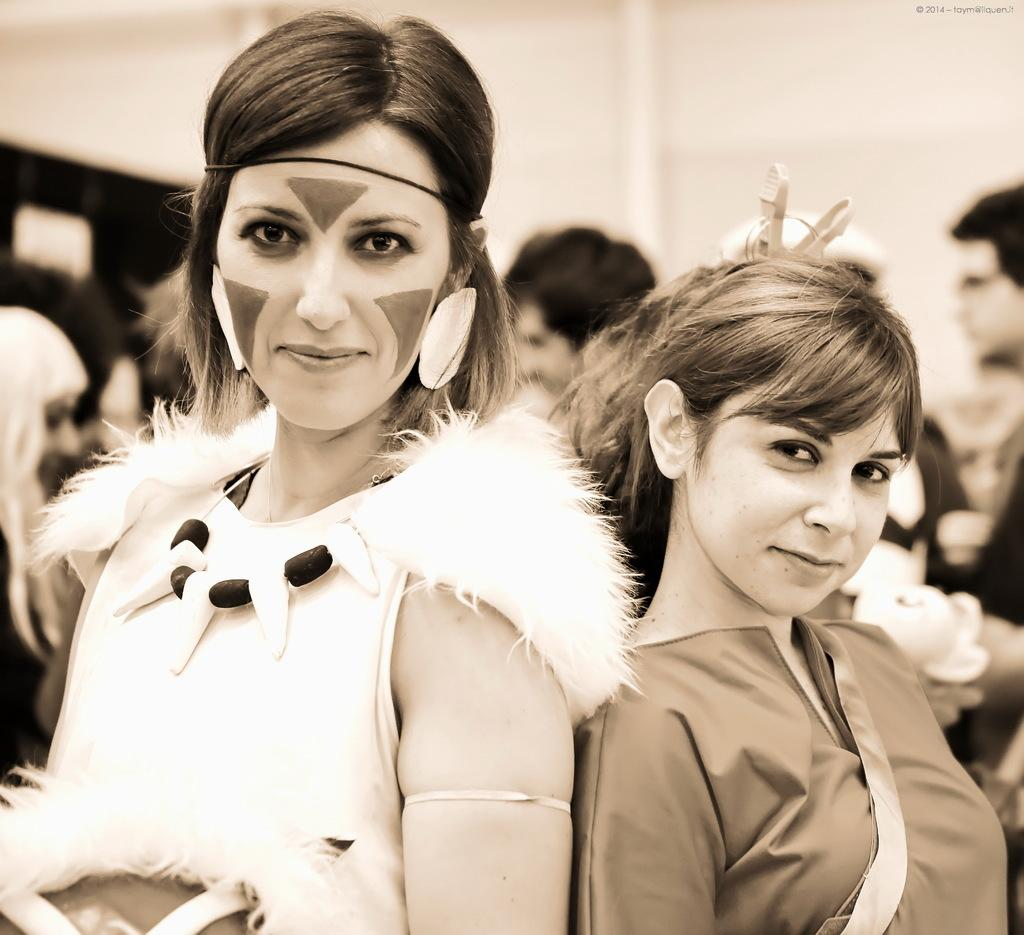How many women are in the image? There are two women in the image. What expression do the women have in the image? The women are smiling in the image. What can be seen in the background of the image? There are people and a wall visible in the background of the image. What type of trousers is the news wearing in the image? There is no news or person wearing trousers present in the image. What is the color of the tongue of the woman on the left? There is no mention of a tongue in the image, and we cannot see the inside of the women's mouths. 